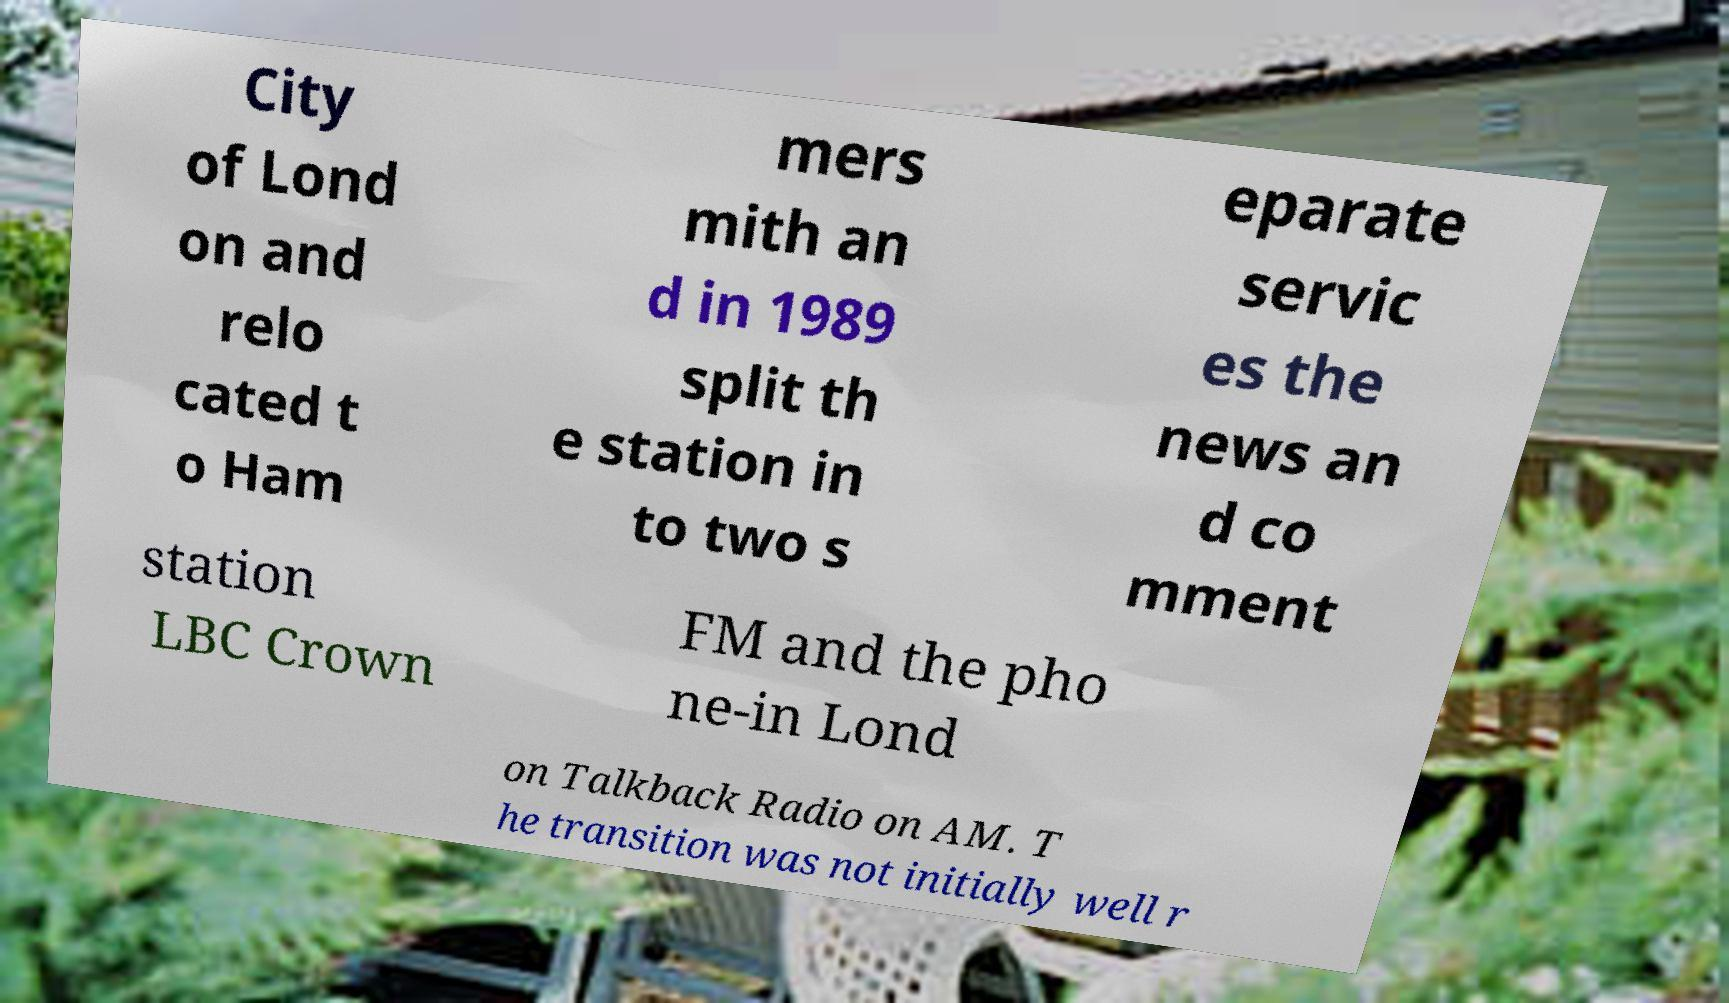Please identify and transcribe the text found in this image. City of Lond on and relo cated t o Ham mers mith an d in 1989 split th e station in to two s eparate servic es the news an d co mment station LBC Crown FM and the pho ne-in Lond on Talkback Radio on AM. T he transition was not initially well r 